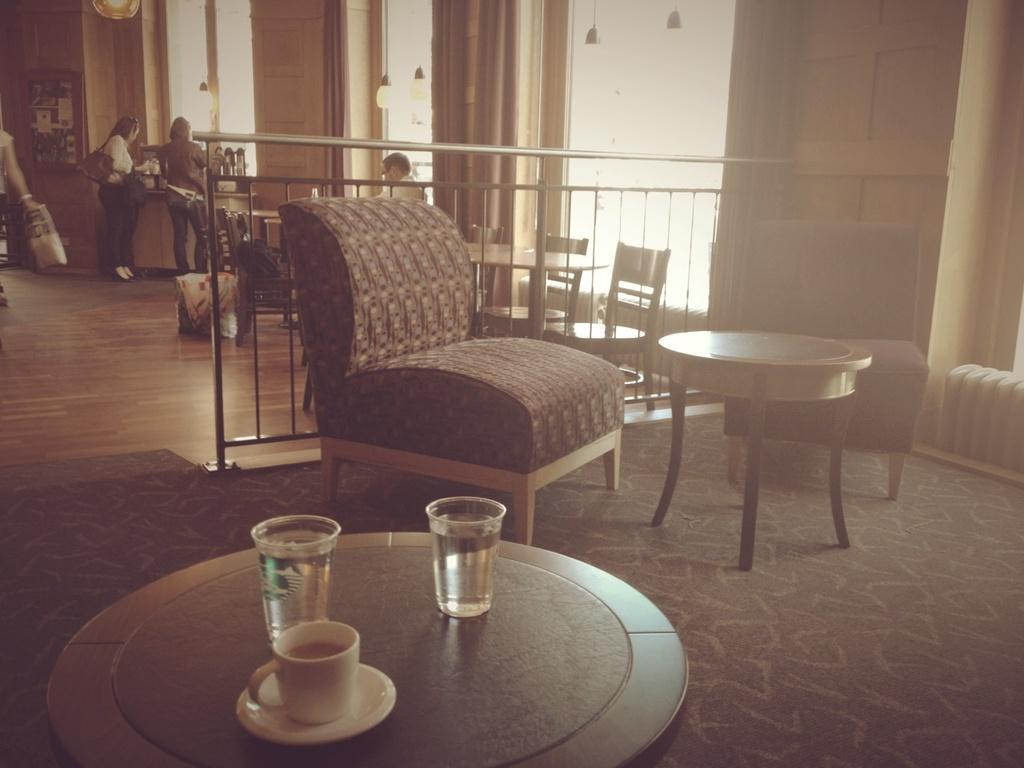What type of furniture is present in the image? There is a chair and tables in the image. What is the surface that the people are standing on in the image? The people are standing on the floor in the image. What is the caption of the image? There is no caption present in the image. What type of animals can be seen at the zoo in the image? There is no zoo or animals present in the image. 